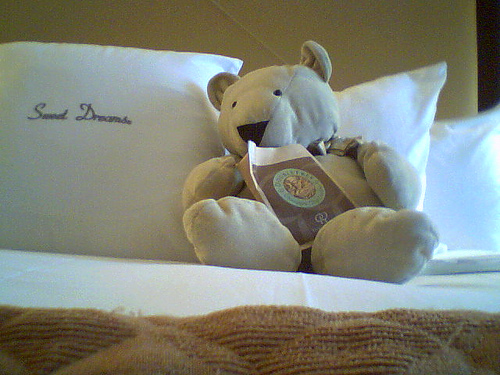<image>Why is the bear holding baby items? It is ambiguous why the bear is holding baby items. It could be a decoration or a gift for a newborn. Why is the bear holding baby items? I don't know why the bear is holding baby items. It could be for decoration, a gift for a newborn, or someone put them there. 